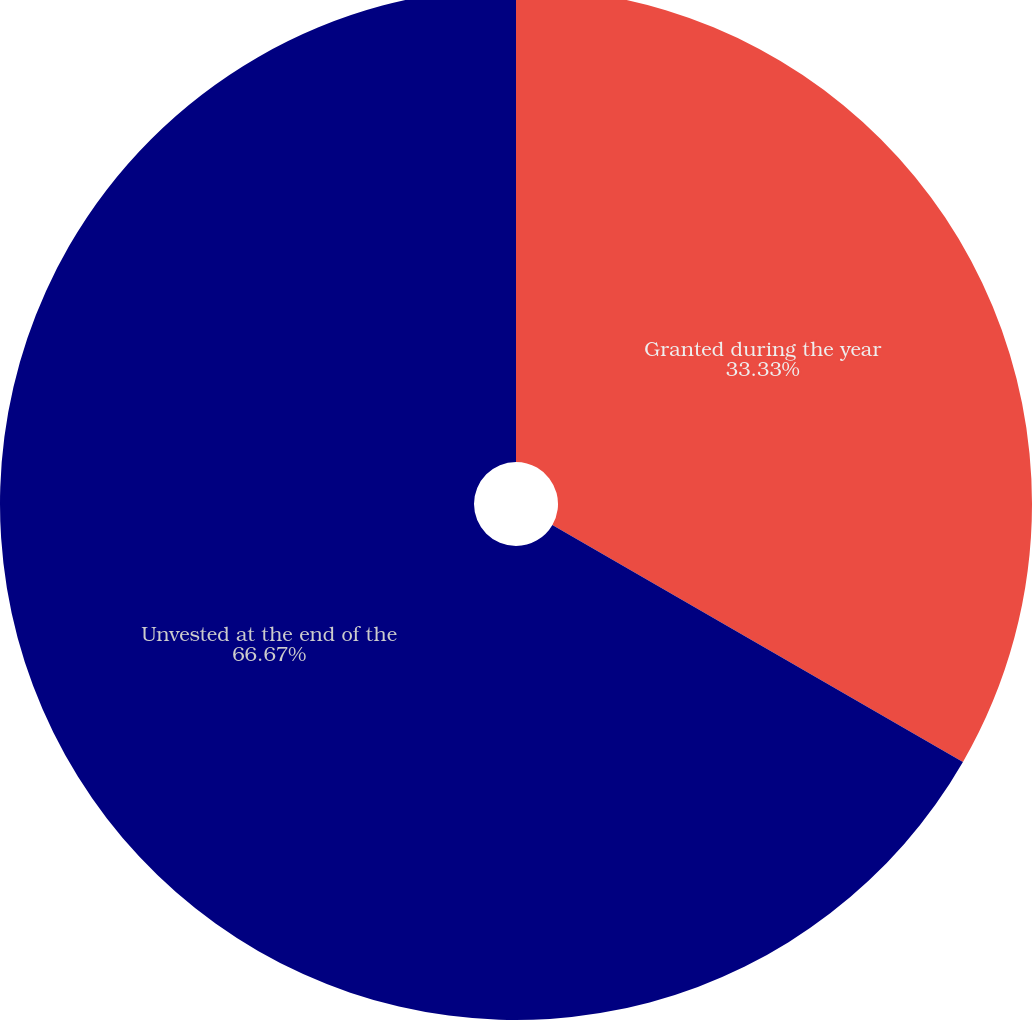Convert chart. <chart><loc_0><loc_0><loc_500><loc_500><pie_chart><fcel>Granted during the year<fcel>Unvested at the end of the<nl><fcel>33.33%<fcel>66.67%<nl></chart> 